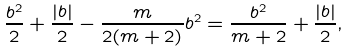<formula> <loc_0><loc_0><loc_500><loc_500>\frac { b ^ { 2 } } { 2 } + \frac { | b | } { 2 } - \frac { m } { 2 ( m + 2 ) } b ^ { 2 } = \frac { b ^ { 2 } } { m + 2 } + \frac { | b | } { 2 } ,</formula> 